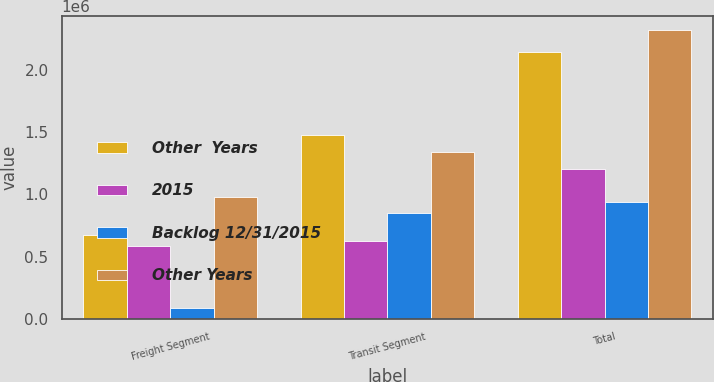Convert chart to OTSL. <chart><loc_0><loc_0><loc_500><loc_500><stacked_bar_chart><ecel><fcel>Freight Segment<fcel>Transit Segment<fcel>Total<nl><fcel>Other  Years<fcel>671910<fcel>1.47497e+06<fcel>2.14688e+06<nl><fcel>2015<fcel>585981<fcel>621736<fcel>1.20772e+06<nl><fcel>Backlog 12/31/2015<fcel>85929<fcel>853238<fcel>939167<nl><fcel>Other Years<fcel>977759<fcel>1.34422e+06<fcel>2.32198e+06<nl></chart> 